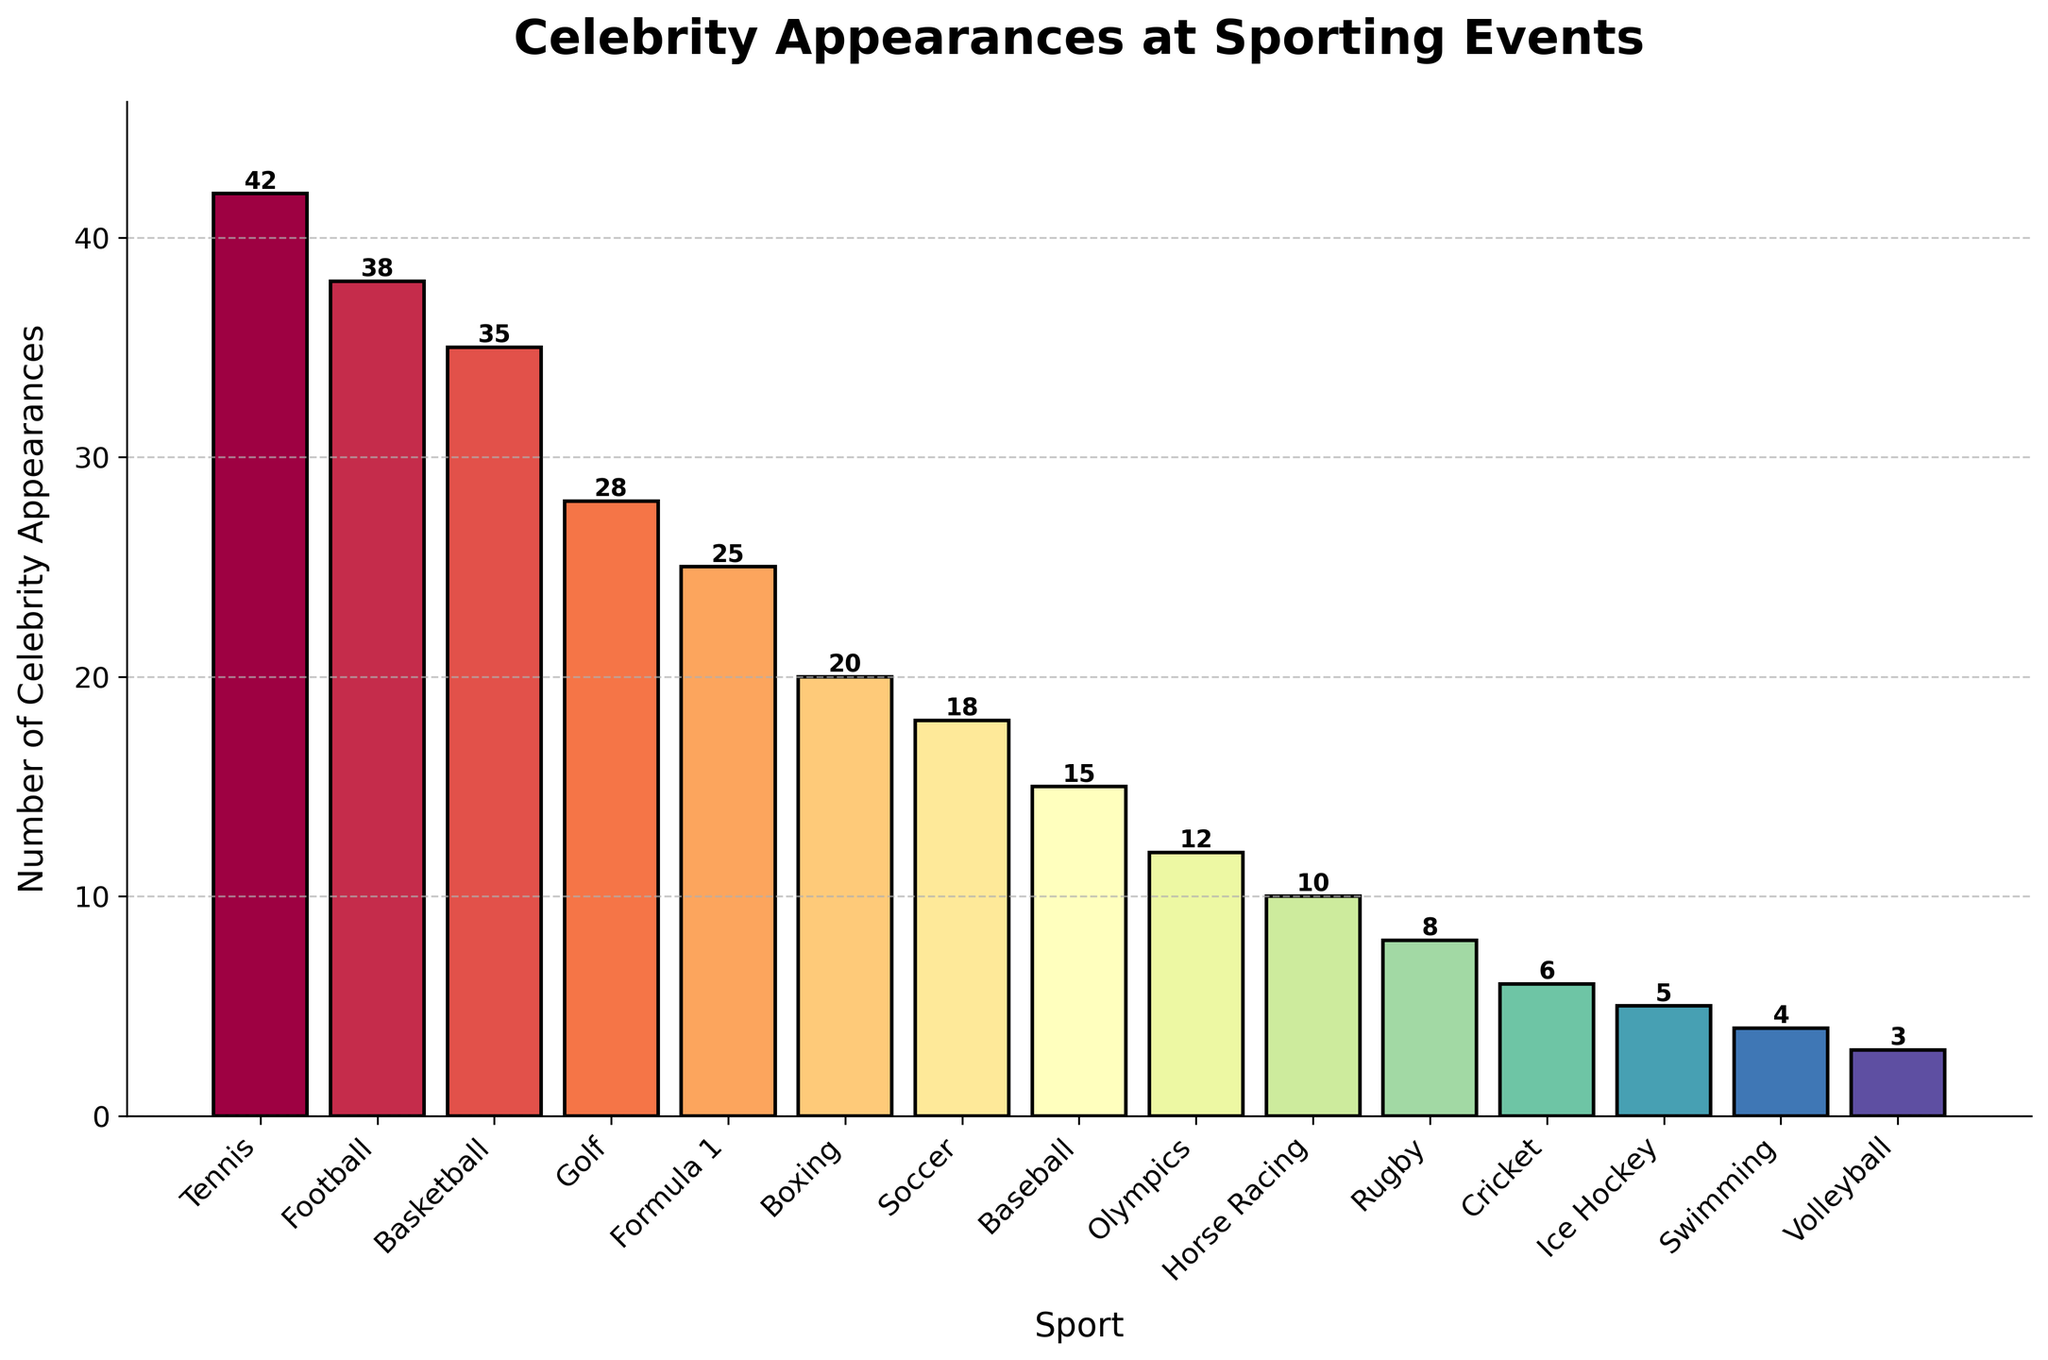Which sport has the highest number of celebrity appearances? By looking at the heights of the bars, Tennis has the tallest bar representing celebrity appearances.
Answer: Tennis Which sport has fewer celebrity appearances, Baseball or Soccer? By comparing the bars for Baseball and Soccer, Baseball has 15 appearances while Soccer has 18.
Answer: Baseball How many more celebrity appearances does Tennis have compared to Golf? Tennis has 42 appearances and Golf has 28. Subtracting 28 from 42 gives 14.
Answer: 14 What's the average number of celebrity appearances across Tennis, Football, and Basketball? Summing the appearances: Tennis (42) + Football (38) + Basketball (35) = 115. Dividing by 3 gives the average: 115 / 3 ≈ 38.33.
Answer: 38.33 What is the total number of celebrity appearances for Swimming, Volleyball, and Ice Hockey? Summing these values: Swimming (4) + Volleyball (3) + Ice Hockey (5) = 12.
Answer: 12 Which sport has the least number of celebrity appearances, and how many appearances are there? By looking for the shortest bar, Volleyball has the least appearances with 3.
Answer: Volleyball, 3 Are there more celebrity appearances in Basketball than Golf? Basketball has 35 appearances while Golf has 28, so Basketball has more.
Answer: Yes How many sports have celebrity appearances greater than 20? Counting the bars taller than 20: Tennis, Football, Basketball, Golf, and Formula 1. There are 5.
Answer: 5 Which sports have fewer than 10 celebrity appearances? By identifying the bars shorter than 10: Rugby, Cricket, Ice Hockey, Swimming, and Volleyball.
Answer: Rugby, Cricket, Ice Hockey, Swimming, Volleyball What’s the sum of celebrity appearances for the three least popular sports? Summing the appearances: Ice Hockey (5) + Swimming (4) + Volleyball (3) = 12.
Answer: 12 